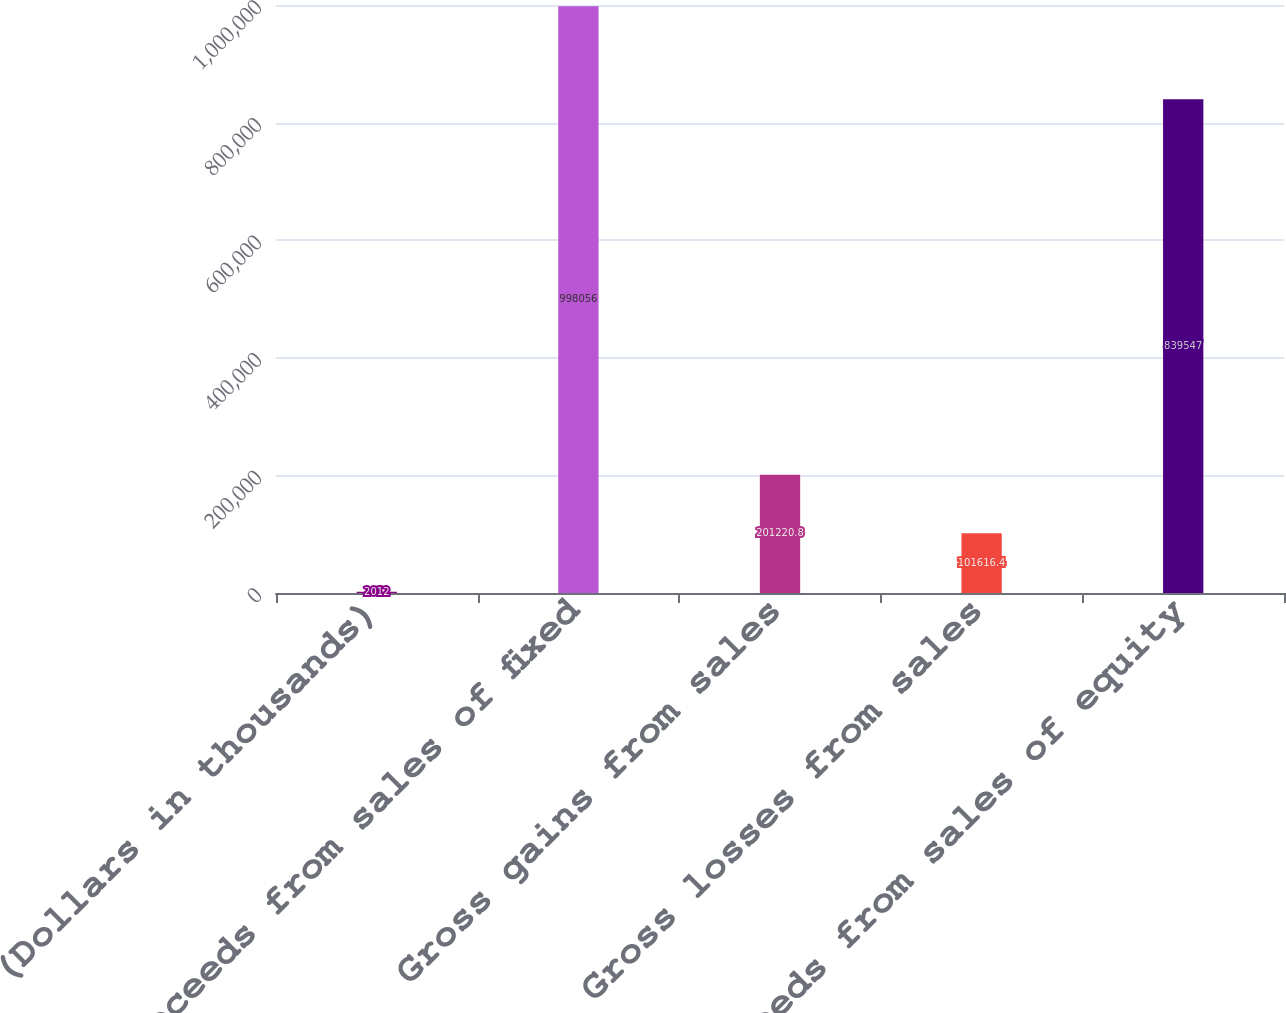Convert chart. <chart><loc_0><loc_0><loc_500><loc_500><bar_chart><fcel>(Dollars in thousands)<fcel>Proceeds from sales of fixed<fcel>Gross gains from sales<fcel>Gross losses from sales<fcel>Proceeds from sales of equity<nl><fcel>2012<fcel>998056<fcel>201221<fcel>101616<fcel>839547<nl></chart> 